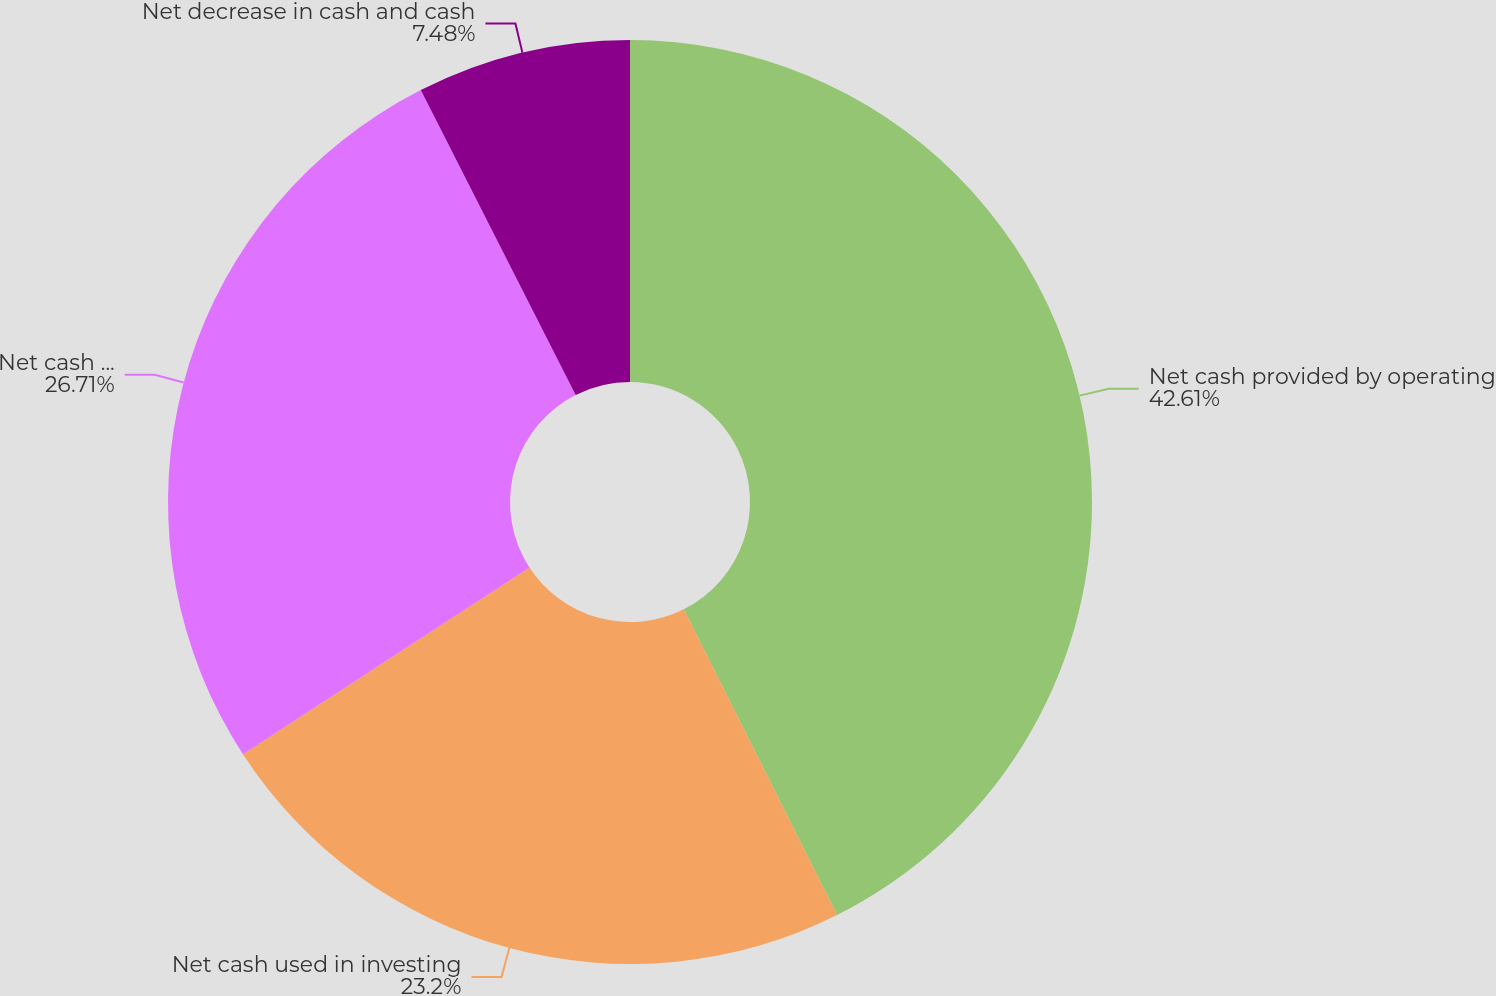Convert chart. <chart><loc_0><loc_0><loc_500><loc_500><pie_chart><fcel>Net cash provided by operating<fcel>Net cash used in investing<fcel>Net cash used in financing<fcel>Net decrease in cash and cash<nl><fcel>42.6%<fcel>23.2%<fcel>26.71%<fcel>7.48%<nl></chart> 